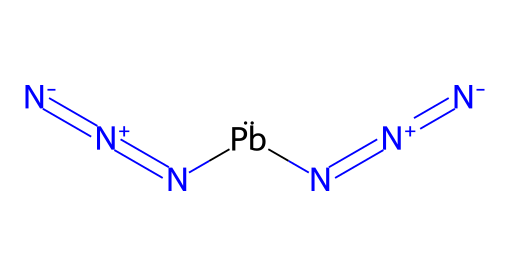What type of chemical is lead azide? Lead azide contains azide groups (N3) and therefore is classified as an azide compound. Azides are characterized by the presence of the -N3 functional group, which is apparent from the structure.
Answer: azide How many nitrogen atoms are in lead azide? Analyzing the SMILES representation, there are three nitrogen atoms in each azide group, and since there are two azide groups in lead azide, the total number of nitrogen atoms is six.
Answer: six How many bonds connect the nitrogen atoms in the azide groups? Each N=N bond represents a double bond in the azide groups, and since there are three nitrogen atoms in each group (connected by two bonds), and there are two azide groups, a total of four double bonds connect all nitrogen atoms.
Answer: four What is the oxidation state of lead in lead azide? To determine the oxidation state, note that the overall charge of lead azide is neutral. Each azide group carries a -1 charge, contributing a total of -2, meaning lead must be in a +2 oxidation state to balance this out.
Answer: +2 Which element in lead azide contributes to its explosive properties? The nitrogen atoms in the azide groups are responsible for the explosive properties, as they can release a significant amount of energy when decomposed due to their instability.
Answer: nitrogen What charge does each azide group have in lead azide? Each azide group is known to carry a -1 charge in the lead azide compound, which is essential for the overall charge balance of the formula.
Answer: -1 